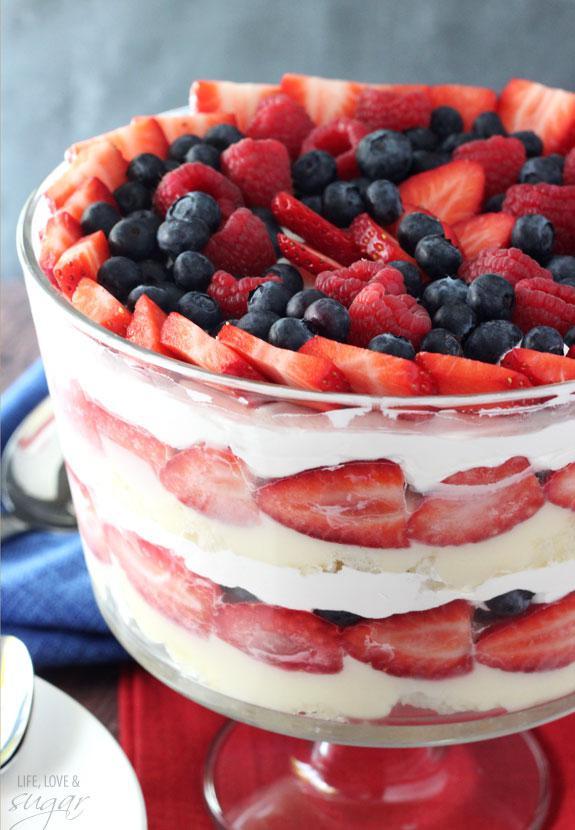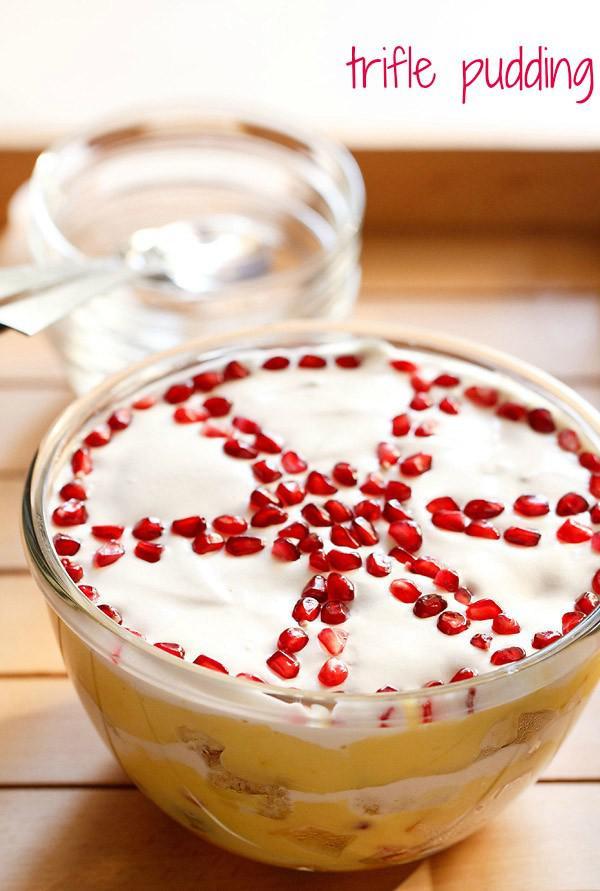The first image is the image on the left, the second image is the image on the right. Examine the images to the left and right. Is the description "The fancy dessert in one image is garnished with chocolate, while the other image shows dessert garnished with sliced fruit." accurate? Answer yes or no. No. The first image is the image on the left, the second image is the image on the right. For the images displayed, is the sentence "An image shows a layered dessert in a footed glass, with a topping that includes sliced strawberries." factually correct? Answer yes or no. Yes. 